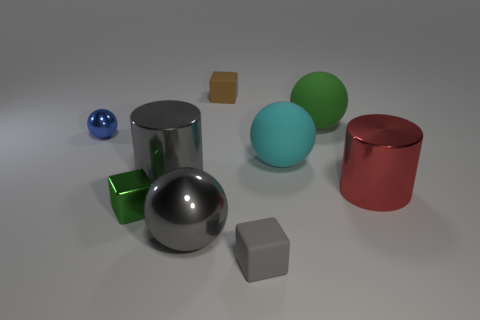There is a thing that is the same color as the small metallic cube; what is its material?
Provide a succinct answer. Rubber. Is there another big metal thing of the same shape as the red shiny thing?
Your answer should be very brief. Yes. There is a object in front of the big gray metal ball; is it the same color as the large object that is in front of the green shiny object?
Your response must be concise. Yes. Do the cylinder behind the large red shiny cylinder and the block that is behind the red metallic thing have the same material?
Provide a succinct answer. No. Is the number of big gray metal spheres that are right of the large cyan matte thing less than the number of large purple things?
Ensure brevity in your answer.  No. There is a big object behind the blue sphere; what color is it?
Your answer should be very brief. Green. What material is the small block behind the large cylinder that is on the left side of the cyan thing made of?
Keep it short and to the point. Rubber. Are there any cyan matte cylinders that have the same size as the green sphere?
Ensure brevity in your answer.  No. What number of objects are either large things to the left of the gray matte object or big rubber things that are behind the cyan rubber sphere?
Provide a succinct answer. 3. Does the sphere behind the blue metal object have the same size as the rubber block to the right of the small brown thing?
Your answer should be compact. No. 